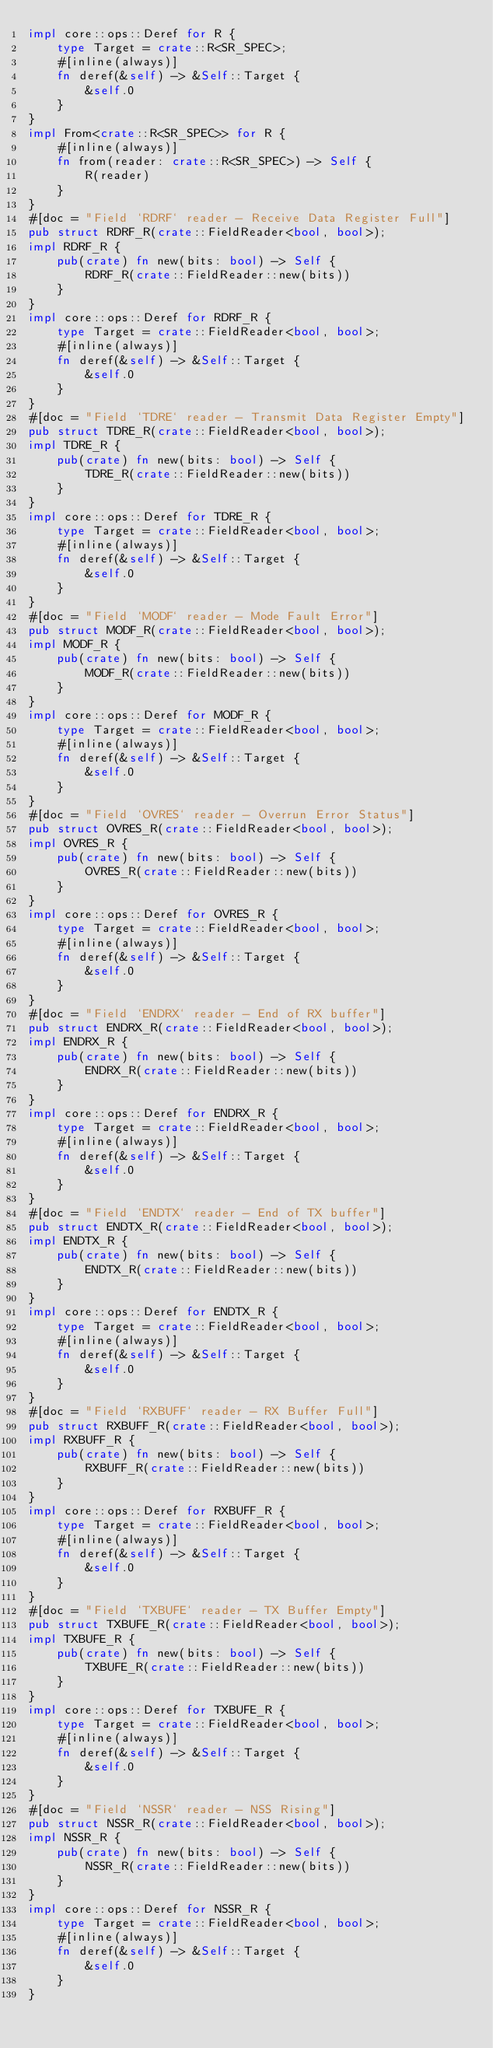Convert code to text. <code><loc_0><loc_0><loc_500><loc_500><_Rust_>impl core::ops::Deref for R {
    type Target = crate::R<SR_SPEC>;
    #[inline(always)]
    fn deref(&self) -> &Self::Target {
        &self.0
    }
}
impl From<crate::R<SR_SPEC>> for R {
    #[inline(always)]
    fn from(reader: crate::R<SR_SPEC>) -> Self {
        R(reader)
    }
}
#[doc = "Field `RDRF` reader - Receive Data Register Full"]
pub struct RDRF_R(crate::FieldReader<bool, bool>);
impl RDRF_R {
    pub(crate) fn new(bits: bool) -> Self {
        RDRF_R(crate::FieldReader::new(bits))
    }
}
impl core::ops::Deref for RDRF_R {
    type Target = crate::FieldReader<bool, bool>;
    #[inline(always)]
    fn deref(&self) -> &Self::Target {
        &self.0
    }
}
#[doc = "Field `TDRE` reader - Transmit Data Register Empty"]
pub struct TDRE_R(crate::FieldReader<bool, bool>);
impl TDRE_R {
    pub(crate) fn new(bits: bool) -> Self {
        TDRE_R(crate::FieldReader::new(bits))
    }
}
impl core::ops::Deref for TDRE_R {
    type Target = crate::FieldReader<bool, bool>;
    #[inline(always)]
    fn deref(&self) -> &Self::Target {
        &self.0
    }
}
#[doc = "Field `MODF` reader - Mode Fault Error"]
pub struct MODF_R(crate::FieldReader<bool, bool>);
impl MODF_R {
    pub(crate) fn new(bits: bool) -> Self {
        MODF_R(crate::FieldReader::new(bits))
    }
}
impl core::ops::Deref for MODF_R {
    type Target = crate::FieldReader<bool, bool>;
    #[inline(always)]
    fn deref(&self) -> &Self::Target {
        &self.0
    }
}
#[doc = "Field `OVRES` reader - Overrun Error Status"]
pub struct OVRES_R(crate::FieldReader<bool, bool>);
impl OVRES_R {
    pub(crate) fn new(bits: bool) -> Self {
        OVRES_R(crate::FieldReader::new(bits))
    }
}
impl core::ops::Deref for OVRES_R {
    type Target = crate::FieldReader<bool, bool>;
    #[inline(always)]
    fn deref(&self) -> &Self::Target {
        &self.0
    }
}
#[doc = "Field `ENDRX` reader - End of RX buffer"]
pub struct ENDRX_R(crate::FieldReader<bool, bool>);
impl ENDRX_R {
    pub(crate) fn new(bits: bool) -> Self {
        ENDRX_R(crate::FieldReader::new(bits))
    }
}
impl core::ops::Deref for ENDRX_R {
    type Target = crate::FieldReader<bool, bool>;
    #[inline(always)]
    fn deref(&self) -> &Self::Target {
        &self.0
    }
}
#[doc = "Field `ENDTX` reader - End of TX buffer"]
pub struct ENDTX_R(crate::FieldReader<bool, bool>);
impl ENDTX_R {
    pub(crate) fn new(bits: bool) -> Self {
        ENDTX_R(crate::FieldReader::new(bits))
    }
}
impl core::ops::Deref for ENDTX_R {
    type Target = crate::FieldReader<bool, bool>;
    #[inline(always)]
    fn deref(&self) -> &Self::Target {
        &self.0
    }
}
#[doc = "Field `RXBUFF` reader - RX Buffer Full"]
pub struct RXBUFF_R(crate::FieldReader<bool, bool>);
impl RXBUFF_R {
    pub(crate) fn new(bits: bool) -> Self {
        RXBUFF_R(crate::FieldReader::new(bits))
    }
}
impl core::ops::Deref for RXBUFF_R {
    type Target = crate::FieldReader<bool, bool>;
    #[inline(always)]
    fn deref(&self) -> &Self::Target {
        &self.0
    }
}
#[doc = "Field `TXBUFE` reader - TX Buffer Empty"]
pub struct TXBUFE_R(crate::FieldReader<bool, bool>);
impl TXBUFE_R {
    pub(crate) fn new(bits: bool) -> Self {
        TXBUFE_R(crate::FieldReader::new(bits))
    }
}
impl core::ops::Deref for TXBUFE_R {
    type Target = crate::FieldReader<bool, bool>;
    #[inline(always)]
    fn deref(&self) -> &Self::Target {
        &self.0
    }
}
#[doc = "Field `NSSR` reader - NSS Rising"]
pub struct NSSR_R(crate::FieldReader<bool, bool>);
impl NSSR_R {
    pub(crate) fn new(bits: bool) -> Self {
        NSSR_R(crate::FieldReader::new(bits))
    }
}
impl core::ops::Deref for NSSR_R {
    type Target = crate::FieldReader<bool, bool>;
    #[inline(always)]
    fn deref(&self) -> &Self::Target {
        &self.0
    }
}</code> 